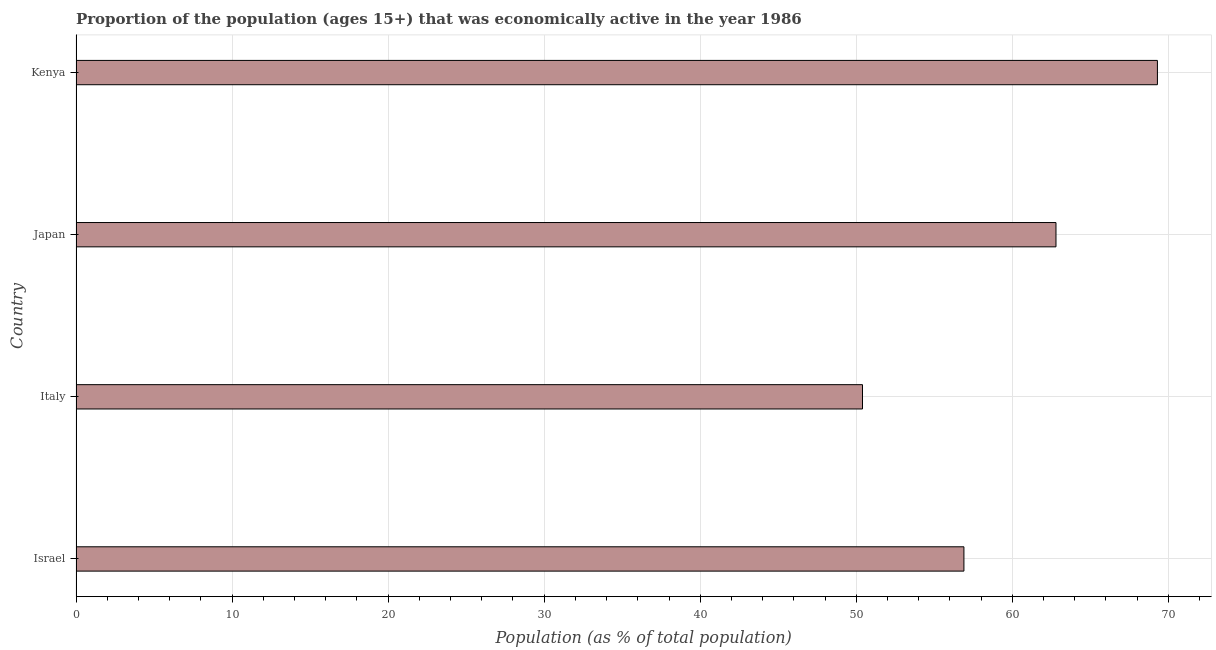What is the title of the graph?
Provide a short and direct response. Proportion of the population (ages 15+) that was economically active in the year 1986. What is the label or title of the X-axis?
Your response must be concise. Population (as % of total population). What is the percentage of economically active population in Japan?
Provide a succinct answer. 62.8. Across all countries, what is the maximum percentage of economically active population?
Offer a terse response. 69.3. Across all countries, what is the minimum percentage of economically active population?
Offer a very short reply. 50.4. In which country was the percentage of economically active population maximum?
Make the answer very short. Kenya. In which country was the percentage of economically active population minimum?
Your response must be concise. Italy. What is the sum of the percentage of economically active population?
Ensure brevity in your answer.  239.4. What is the average percentage of economically active population per country?
Give a very brief answer. 59.85. What is the median percentage of economically active population?
Ensure brevity in your answer.  59.85. What is the ratio of the percentage of economically active population in Israel to that in Italy?
Your response must be concise. 1.13. Is the difference between the percentage of economically active population in Japan and Kenya greater than the difference between any two countries?
Provide a short and direct response. No. What is the difference between the highest and the second highest percentage of economically active population?
Provide a succinct answer. 6.5. Is the sum of the percentage of economically active population in Israel and Kenya greater than the maximum percentage of economically active population across all countries?
Keep it short and to the point. Yes. What is the difference between the highest and the lowest percentage of economically active population?
Provide a short and direct response. 18.9. How many bars are there?
Offer a very short reply. 4. Are all the bars in the graph horizontal?
Your response must be concise. Yes. How many countries are there in the graph?
Ensure brevity in your answer.  4. What is the Population (as % of total population) in Israel?
Offer a terse response. 56.9. What is the Population (as % of total population) in Italy?
Keep it short and to the point. 50.4. What is the Population (as % of total population) in Japan?
Offer a very short reply. 62.8. What is the Population (as % of total population) in Kenya?
Your answer should be compact. 69.3. What is the difference between the Population (as % of total population) in Israel and Italy?
Your answer should be compact. 6.5. What is the difference between the Population (as % of total population) in Italy and Japan?
Your answer should be compact. -12.4. What is the difference between the Population (as % of total population) in Italy and Kenya?
Keep it short and to the point. -18.9. What is the ratio of the Population (as % of total population) in Israel to that in Italy?
Ensure brevity in your answer.  1.13. What is the ratio of the Population (as % of total population) in Israel to that in Japan?
Provide a short and direct response. 0.91. What is the ratio of the Population (as % of total population) in Israel to that in Kenya?
Ensure brevity in your answer.  0.82. What is the ratio of the Population (as % of total population) in Italy to that in Japan?
Give a very brief answer. 0.8. What is the ratio of the Population (as % of total population) in Italy to that in Kenya?
Offer a very short reply. 0.73. What is the ratio of the Population (as % of total population) in Japan to that in Kenya?
Provide a succinct answer. 0.91. 